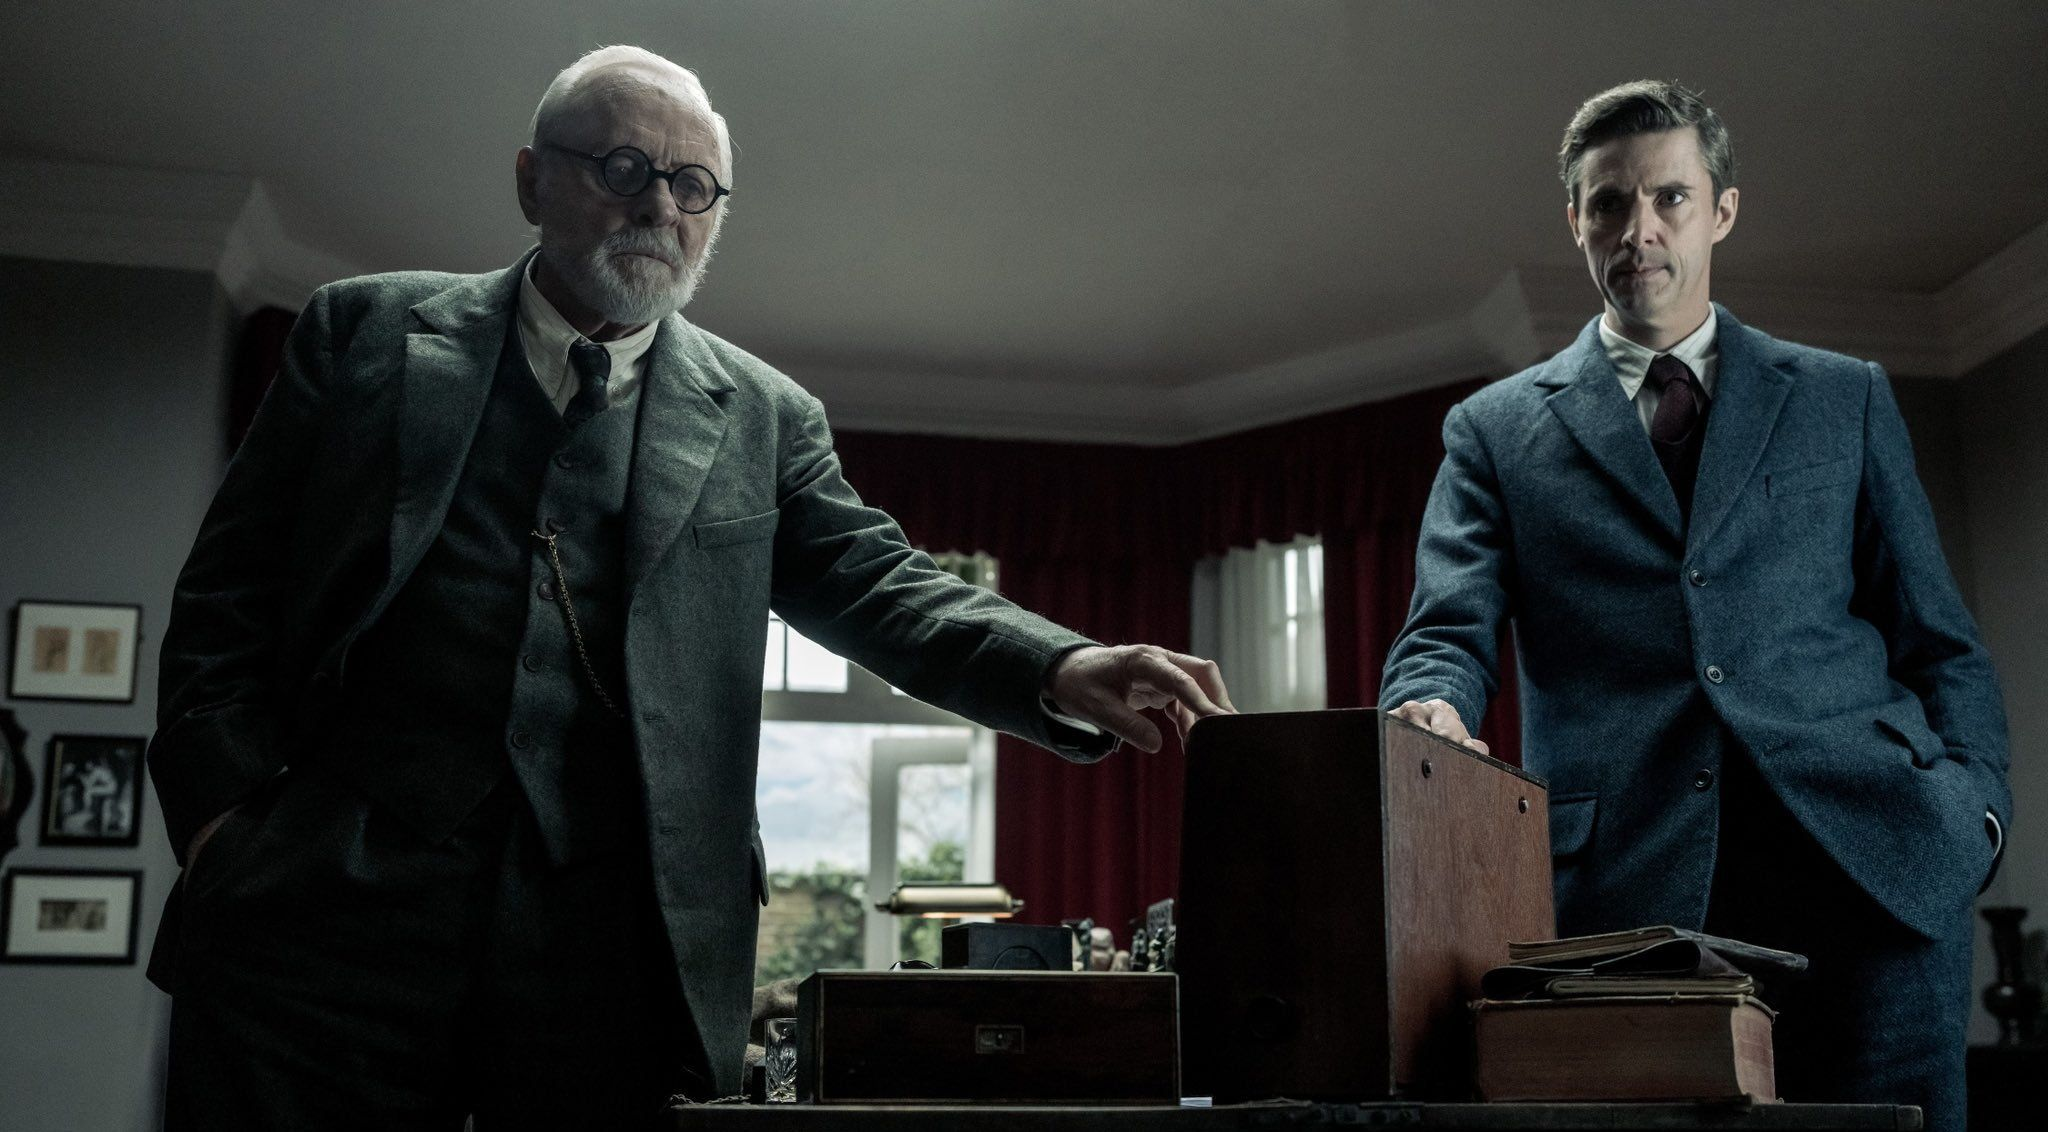What do you think is inside the box on the table? The box on the table adds an element of mystery to the scene. It could potentially contain important documents, a valuable item, or something significant to the plot of the story. Its presence between the two men hints at its importance in their conversation or conflict. 